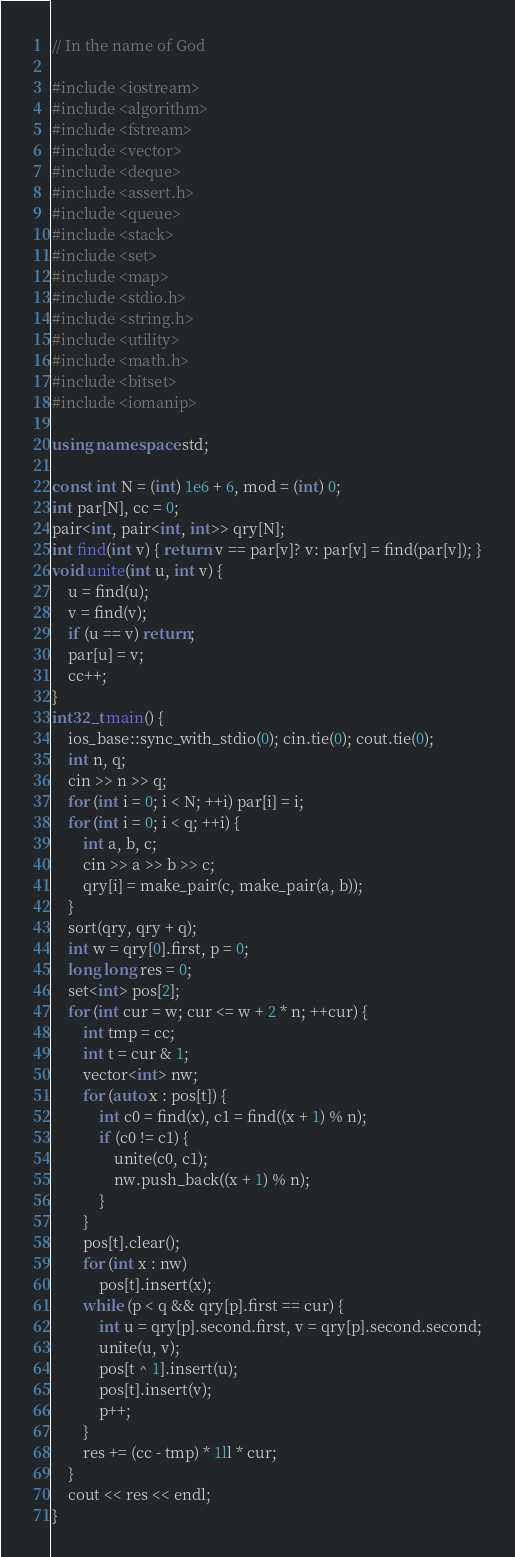<code> <loc_0><loc_0><loc_500><loc_500><_C++_>// In the name of God

#include <iostream>
#include <algorithm>
#include <fstream>
#include <vector>
#include <deque>
#include <assert.h>
#include <queue>
#include <stack>
#include <set>
#include <map>
#include <stdio.h>
#include <string.h>
#include <utility>
#include <math.h>
#include <bitset>
#include <iomanip>

using namespace std;

const int N = (int) 1e6 + 6, mod = (int) 0;
int par[N], cc = 0;
pair<int, pair<int, int>> qry[N];
int find(int v) { return v == par[v]? v: par[v] = find(par[v]); }
void unite(int u, int v) {
    u = find(u);
    v = find(v);
    if (u == v) return;
    par[u] = v;
    cc++;
}
int32_t main() {
    ios_base::sync_with_stdio(0); cin.tie(0); cout.tie(0);
    int n, q;
    cin >> n >> q;
    for (int i = 0; i < N; ++i) par[i] = i;
    for (int i = 0; i < q; ++i) {
        int a, b, c;
        cin >> a >> b >> c;
        qry[i] = make_pair(c, make_pair(a, b));
    }
    sort(qry, qry + q);
    int w = qry[0].first, p = 0;
    long long res = 0;
    set<int> pos[2];
    for (int cur = w; cur <= w + 2 * n; ++cur) {
        int tmp = cc;
        int t = cur & 1;
        vector<int> nw;
        for (auto x : pos[t]) {
            int c0 = find(x), c1 = find((x + 1) % n);
            if (c0 != c1) {
                unite(c0, c1);
                nw.push_back((x + 1) % n);
            }
        }
        pos[t].clear();
        for (int x : nw)
            pos[t].insert(x);
        while (p < q && qry[p].first == cur) {
            int u = qry[p].second.first, v = qry[p].second.second;
            unite(u, v);
            pos[t ^ 1].insert(u);
            pos[t].insert(v);
            p++;
        }
        res += (cc - tmp) * 1ll * cur;
    }
    cout << res << endl;
}</code> 